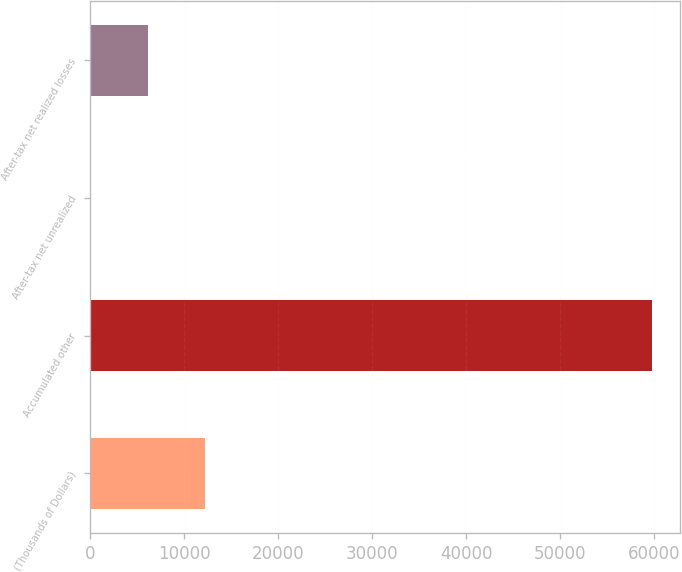Convert chart to OTSL. <chart><loc_0><loc_0><loc_500><loc_500><bar_chart><fcel>(Thousands of Dollars)<fcel>Accumulated other<fcel>After-tax net unrealized<fcel>After-tax net realized losses<nl><fcel>12257.8<fcel>59753<fcel>12<fcel>6134.9<nl></chart> 